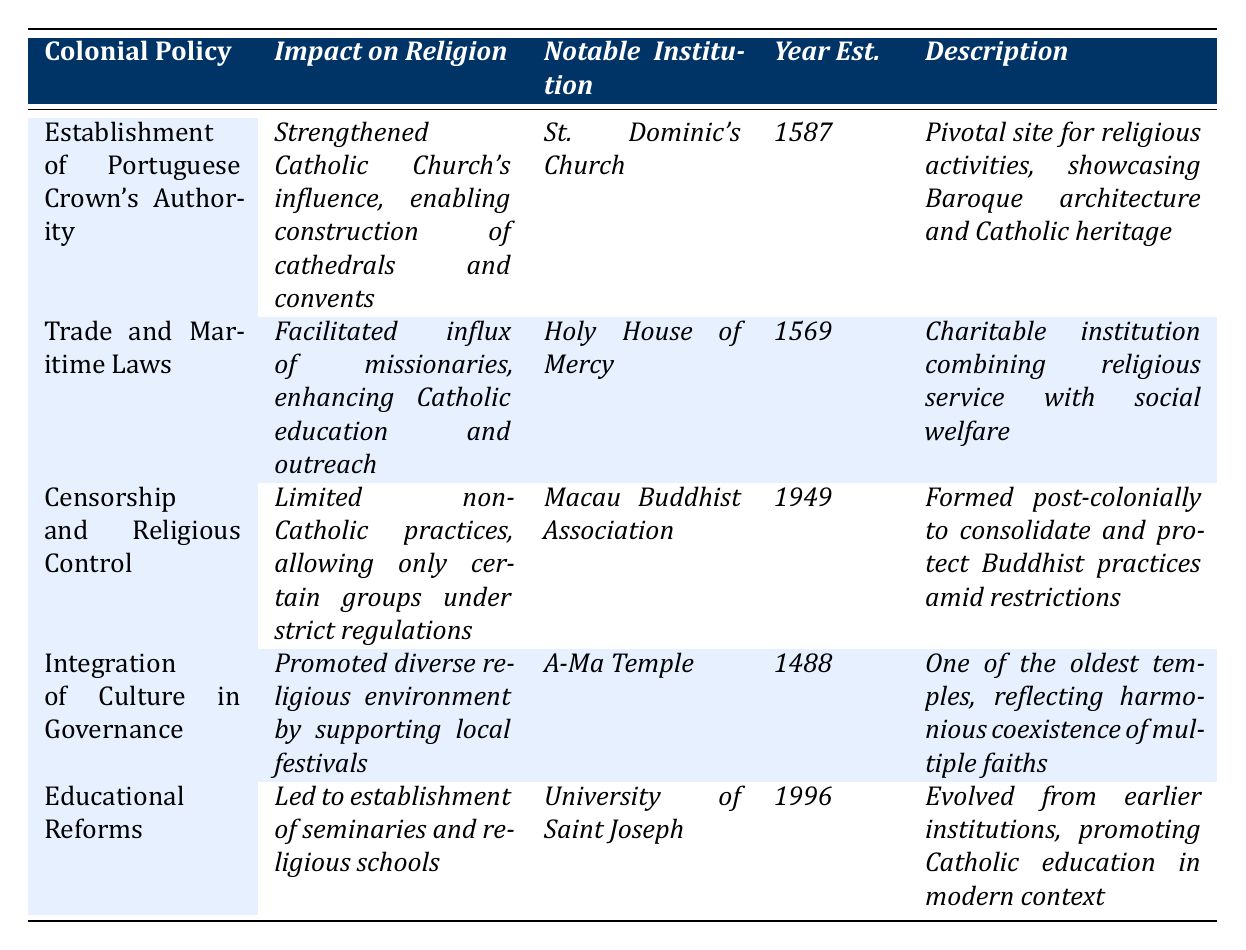What was the notable institution established due to the Establishment of Portuguese Crown's Authority? The table lists "St. Dominic's Church" as the notable institution associated with the Establishment of the Portuguese Crown's Authority.
Answer: St. Dominic's Church In what year was the Holy House of Mercy established? From the table, the establishment year of the Holy House of Mercy is clearly marked as "1569."
Answer: 1569 True or False: The Macau Buddhist Association was established before the Holy House of Mercy. The table indicates that the Holy House of Mercy was established in 1569 and the Macau Buddhist Association in 1949, making this statement false.
Answer: False What impact did Educational Reforms have on religious institutions? According to the table, Educational Reforms led to the establishment of seminaries and religious schools, thereby enhancing theological education and the clerical workforce.
Answer: Enhanced theological education and clerical workforce Which religious institution is the oldest according to the table? The A-Ma Temple is listed as being established in 1488, making it the oldest institution in the table compared to others.
Answer: A-Ma Temple How many years apart were St. Dominic's Church and the Holy House of Mercy established? St. Dominic's Church was established in 1587 and the Holy House of Mercy in 1569. The difference is 1587 - 1569 = 18 years.
Answer: 18 years What was the impact of Censorship and Religious Control on religious practices? The table states that it limited non-Catholic practices, only allowing certain groups under strict regulations.
Answer: Limited non-Catholic practices Which notable institution reflects the harmonious coexistence of multiple faiths, according to the table? The A-Ma Temple is described as a temple reflecting the harmonious coexistence of multiple faiths in Macau.
Answer: A-Ma Temple If you consider all the years of establishment, what is the average year of establishment of the listed institutions? The years of establishment are 1587, 1569, 1949, 1488, and 1996. Calculating the average: (1587 + 1569 + 1949 + 1488 + 1996) / 5 = 1718.6, which rounds to approximately 1719.
Answer: 1719 How did the Integration of Culture in Governance influence local religious festivals? The table mentions that it promoted a diverse religious environment by supporting local festivals, including Taoist and Buddhist activities.
Answer: Promoted a diverse religious environment Was the establishment of the University of Saint Joseph directly related to the Portuguese Crown's authority? The table does not indicate a direct relationship but states the university evolved from earlier institutions, suggesting indirect influence rather than a direct relationship with the Portuguese Crown’s authority.
Answer: No 